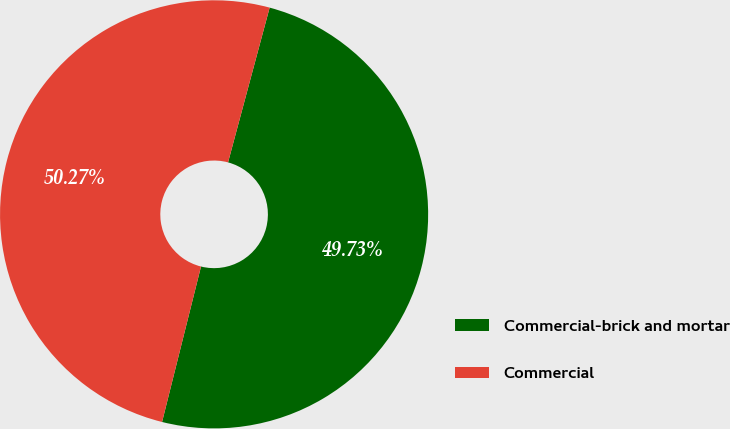<chart> <loc_0><loc_0><loc_500><loc_500><pie_chart><fcel>Commercial-brick and mortar<fcel>Commercial<nl><fcel>49.73%<fcel>50.27%<nl></chart> 